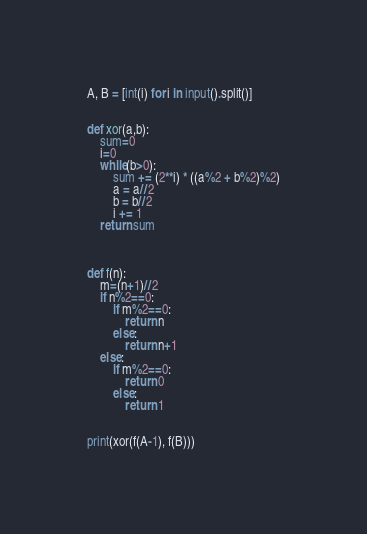<code> <loc_0><loc_0><loc_500><loc_500><_Python_>A, B = [int(i) for i in input().split()]


def xor(a,b):
    sum=0
    i=0
    while(b>0):
        sum += (2**i) * ((a%2 + b%2)%2)
        a = a//2
        b = b//2
        i += 1
    return sum



def f(n):
    m=(n+1)//2
    if n%2==0:
        if m%2==0:
            return n
        else:
            return n+1
    else:
        if m%2==0:
            return 0
        else:
            return 1


print(xor(f(A-1), f(B)))
</code> 